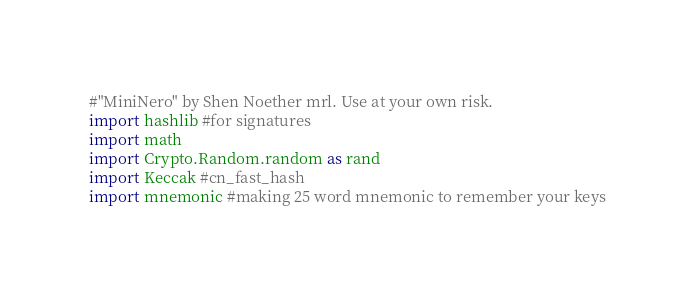Convert code to text. <code><loc_0><loc_0><loc_500><loc_500><_Python_>#"MiniNero" by Shen Noether mrl. Use at your own risk.
import hashlib #for signatures
import math
import Crypto.Random.random as rand
import Keccak #cn_fast_hash
import mnemonic #making 25 word mnemonic to remember your keys</code> 